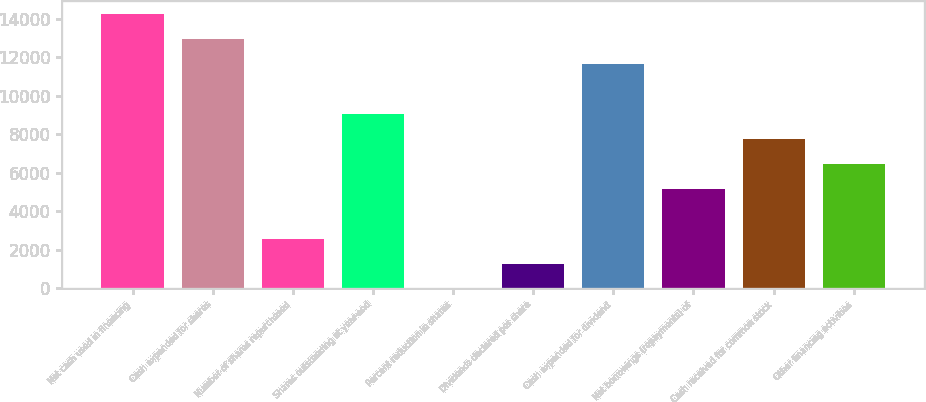Convert chart to OTSL. <chart><loc_0><loc_0><loc_500><loc_500><bar_chart><fcel>Net cash used in financing<fcel>Cash expended for shares<fcel>Number of shares repurchased<fcel>Shares outstanding at year-end<fcel>Percent reduction in shares<fcel>Dividends declared per share<fcel>Cash expended for dividend<fcel>Net borrowings (repayments) of<fcel>Cash received for common stock<fcel>Other financing activities<nl><fcel>14230.5<fcel>12937<fcel>2589<fcel>9056.5<fcel>2<fcel>1295.5<fcel>11643.5<fcel>5176<fcel>7763<fcel>6469.5<nl></chart> 